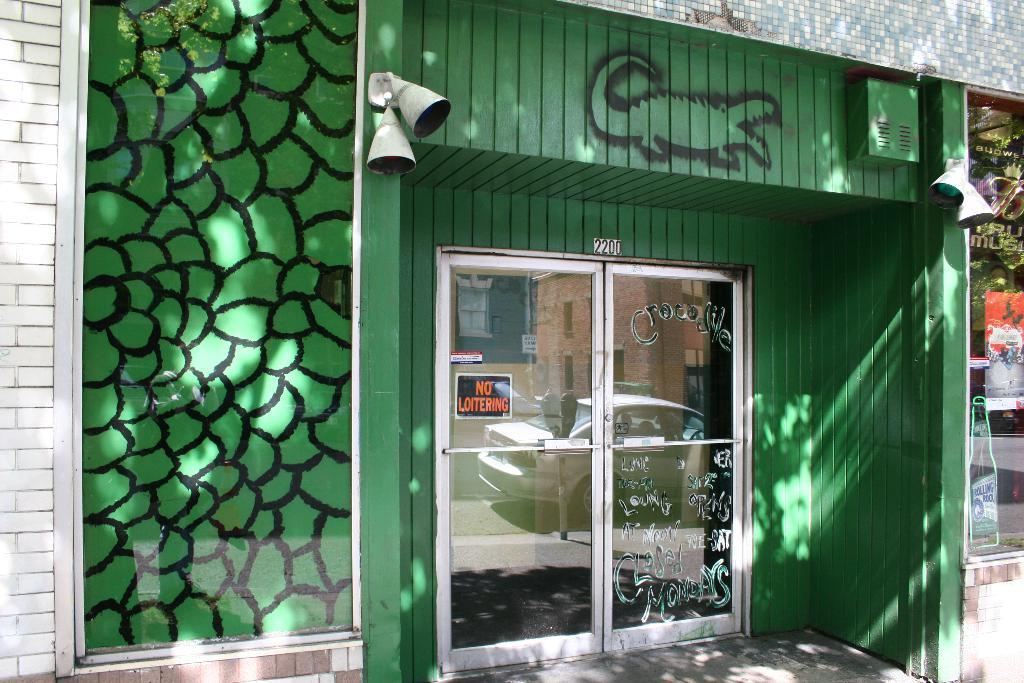What type of structure is visible in the image? There is a building in the image. What feature can be seen in the middle of the building? The building has a glass door in the middle. What other glass feature is present on the building? The building has a glass window on the right side. Reasoning: Let's think step by step by step in order to produce the conversation. We start by identifying the main subject in the image, which is the building. Then, we expand the conversation to include specific details about the building, such as the glass door and window. Each question is designed to elicit a specific detail about the image that is known from the provided facts. Absurd Question/Answer: What type of popcorn is being sold at the building in the image? There is no indication of popcorn or any type of sale in the image. 